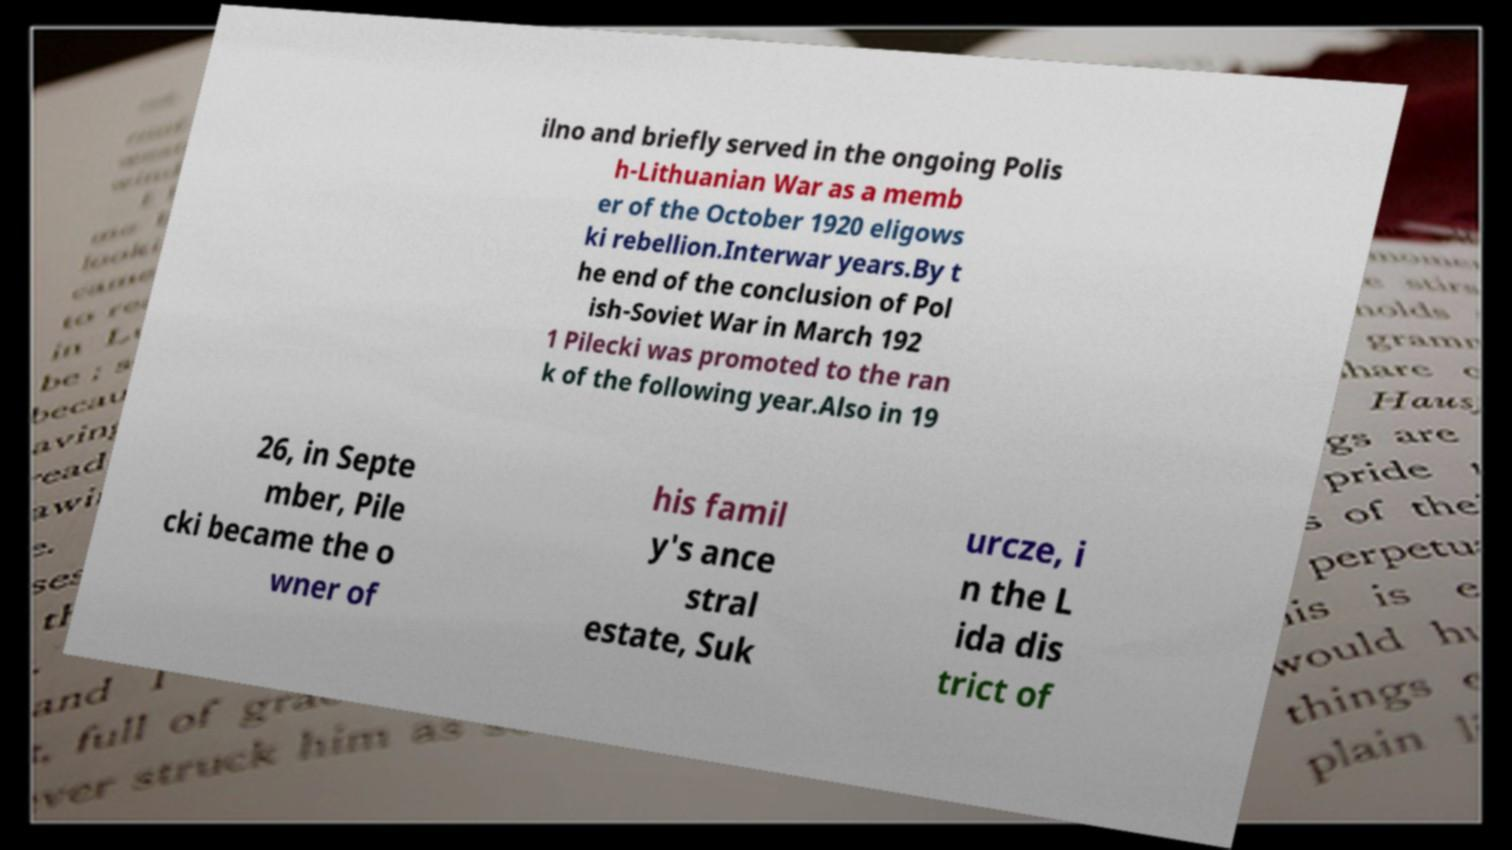For documentation purposes, I need the text within this image transcribed. Could you provide that? ilno and briefly served in the ongoing Polis h-Lithuanian War as a memb er of the October 1920 eligows ki rebellion.Interwar years.By t he end of the conclusion of Pol ish-Soviet War in March 192 1 Pilecki was promoted to the ran k of the following year.Also in 19 26, in Septe mber, Pile cki became the o wner of his famil y's ance stral estate, Suk urcze, i n the L ida dis trict of 